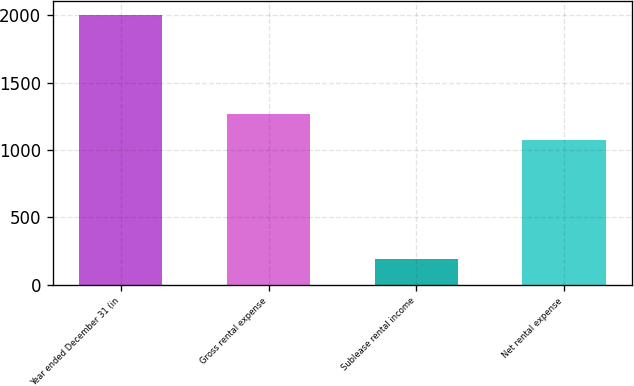Convert chart. <chart><loc_0><loc_0><loc_500><loc_500><bar_chart><fcel>Year ended December 31 (in<fcel>Gross rental expense<fcel>Sublease rental income<fcel>Net rental expense<nl><fcel>2005<fcel>1269<fcel>192<fcel>1077<nl></chart> 